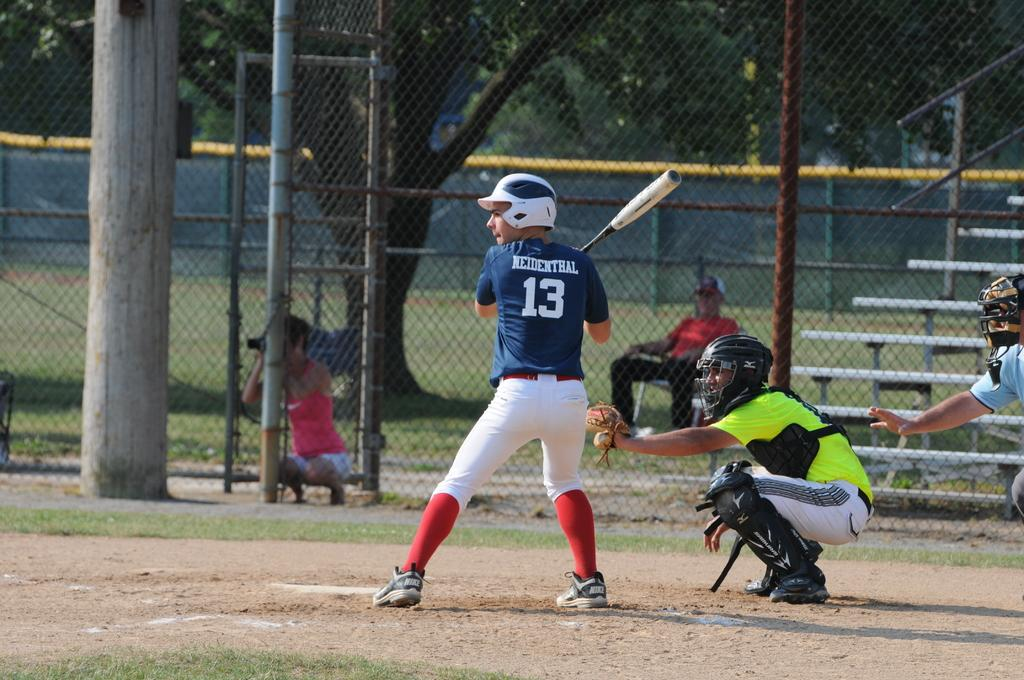<image>
Present a compact description of the photo's key features. A boy at bat with 13 on his jersey in a baseball game. 